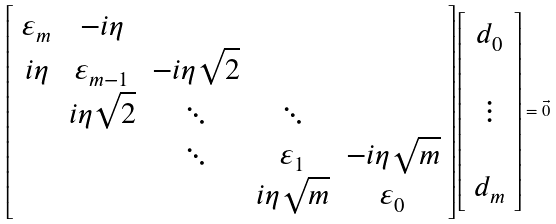Convert formula to latex. <formula><loc_0><loc_0><loc_500><loc_500>\left [ \begin{array} { c c c c c } \varepsilon _ { m } & - i \eta & & & \\ i \eta & \varepsilon _ { m - 1 } & - i \eta \sqrt { 2 } & & \\ & i \eta \sqrt { 2 } & \ddots & \ddots & \\ & & \ddots & \varepsilon _ { 1 } & - i \eta \sqrt { m } \\ & & & i \eta \sqrt { m } & \varepsilon _ { 0 } \end{array} \right ] \left [ \begin{array} { c } d _ { 0 } \\ \\ \vdots \\ \\ d _ { m } \end{array} \right ] = \vec { 0 }</formula> 